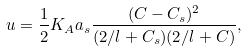<formula> <loc_0><loc_0><loc_500><loc_500>u = \frac { 1 } { 2 } K _ { A } a _ { s } \frac { ( C - C _ { s } ) ^ { 2 } } { ( 2 / l + C _ { s } ) ( 2 / l + C ) } ,</formula> 